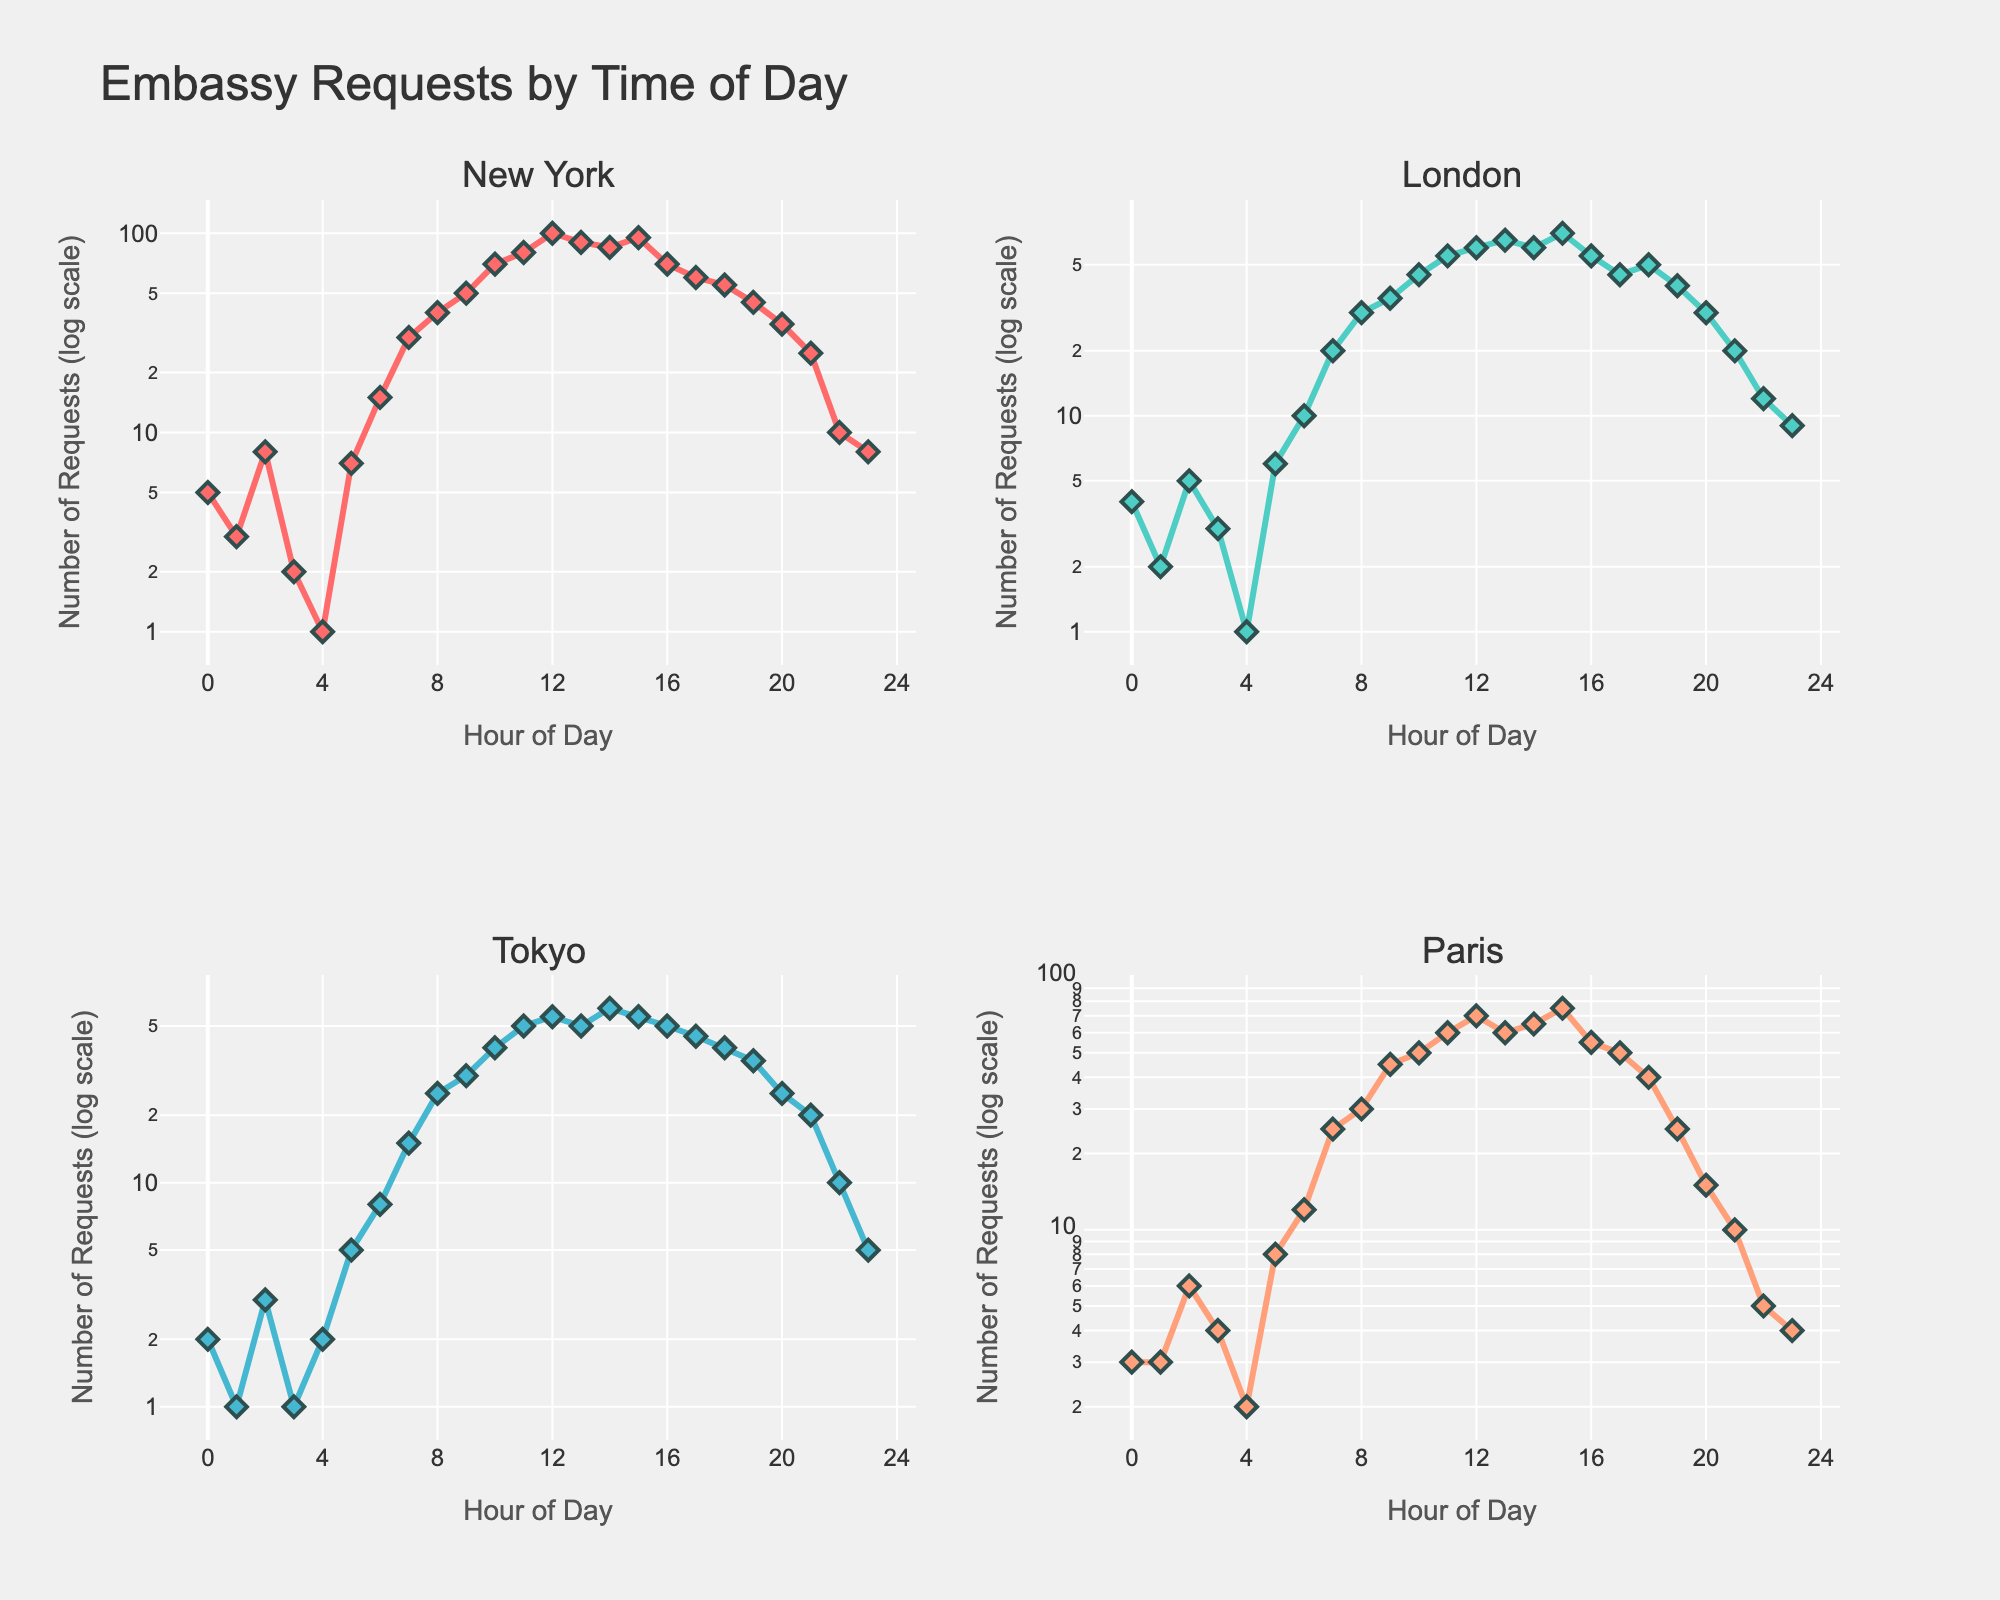Which city has the highest number of embassy requests at 12 PM? Look at the 12 PM (noon) data points for each city and compare their log-scaled values. New York has 100 requests, London has 60, Tokyo has 55, and Paris has 70.
Answer: New York How does the number of requests in Tokyo at 10 AM compare with those in London at the same time? Compare the 10 AM point for Tokyo (40 requests) against the 10 AM point for London (45 requests).
Answer: London has more requests What time of day sees the peak number of requests for New York, and what is that number? Identify the highest data point on the log scale for New York from 0 to 23 hours. The peak is at 12 PM with 100 requests.
Answer: 12 PM with 100 requests What is the combined number of embassy requests at 8 AM across all cities? Sum the values for each city at 8 AM. New York at 8 AM has 40, London has 30, Tokyo has 25, Paris has 30. Total is 40 + 30 + 25 + 30.
Answer: 125 Which city shows the steepest increase in requests between 6 AM and 7 AM? Review the slopes between 6 AM and 7 AM for each city. New York increases from 15 to 30 (15 requests), London from 10 to 20 (10 requests), Tokyo from 8 to 15 (7 requests), and Paris from 12 to 25 (13 requests). New York has the steepest increase.
Answer: New York When do the first substantial increases in requests occur in Paris? Analyze for the first notable or sizable jump in the log-scaled requests in Paris. This happens between 4 and 5 AM, going from 2 to 8 requests.
Answer: 5 AM What is the trend of embassy requests in New York from 4 PM to 8 PM? Examine the log-scaled y-axis points between the hours 16 (4 PM) and 20 (8 PM) for New York. Requests drop from 70 to 35 in a roughly linear decline.
Answer: Downward trend Compare the log-scale trends for Tokyo and Paris overall. Which city shows a more consistent pattern? Observe the log-scale patterns: Tokyo has more linear growth and consistent activity throughout the day whereas Paris has more variabilities. Tokyo's patterns appear more consistent.
Answer: Tokyo How many hours in London have fewer than 10 requests? Count the data points in London where the log-scaled values are below 10. These occur at hours 0, 1, 2, 3, 4, 5, 21, and 23.
Answer: 8 What is the range of embassy requests observed in Paris throughout the entire day? Determine the minimum and maximum requests for Paris on the log scale. The minimum is 2 requests at 4 AM, and the maximum is 75 at 3 PM. The range is 75 - 2.
Answer: 73 